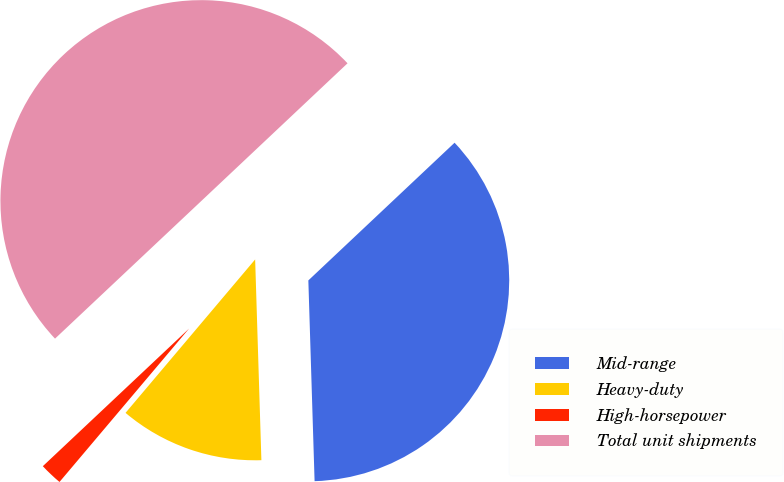<chart> <loc_0><loc_0><loc_500><loc_500><pie_chart><fcel>Mid-range<fcel>Heavy-duty<fcel>High-horsepower<fcel>Total unit shipments<nl><fcel>36.53%<fcel>11.66%<fcel>1.82%<fcel>50.0%<nl></chart> 